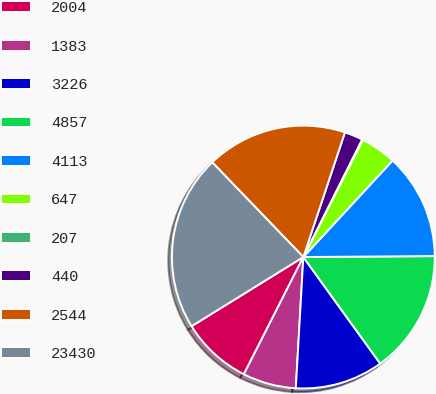Convert chart. <chart><loc_0><loc_0><loc_500><loc_500><pie_chart><fcel>2004<fcel>1383<fcel>3226<fcel>4857<fcel>4113<fcel>647<fcel>207<fcel>440<fcel>2544<fcel>23430<nl><fcel>8.71%<fcel>6.56%<fcel>10.86%<fcel>15.17%<fcel>13.01%<fcel>4.4%<fcel>0.1%<fcel>2.25%<fcel>17.32%<fcel>21.63%<nl></chart> 